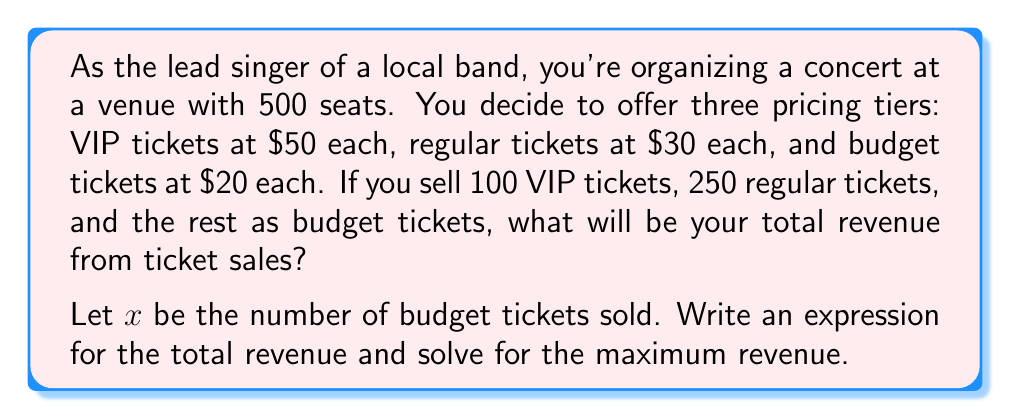Could you help me with this problem? Let's approach this step-by-step:

1) First, let's identify the known quantities:
   - Total seats: 500
   - VIP tickets: 100 at $50 each
   - Regular tickets: 250 at $30 each
   - Budget tickets: $x$ at $20 each

2) We know that the total number of tickets must equal 500:
   $100 + 250 + x = 500$
   $x = 500 - 350 = 150$

3) Now, let's write an expression for the total revenue:
   $R = 50(100) + 30(250) + 20x$

4) Simplify:
   $R = 5000 + 7500 + 20x$
   $R = 12500 + 20x$

5) Now that we know $x = 150$, we can calculate the total revenue:
   $R = 12500 + 20(150)$
   $R = 12500 + 3000$
   $R = 15500$

Therefore, the total revenue from ticket sales will be $15,500.
Answer: $15,500 